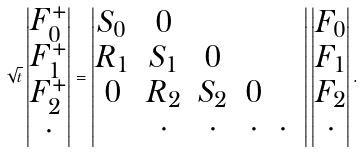Convert formula to latex. <formula><loc_0><loc_0><loc_500><loc_500>\sqrt { t } \begin{vmatrix} F ^ { + } _ { 0 } \\ F ^ { + } _ { 1 } \\ F ^ { + } _ { 2 } \\ \cdot \end{vmatrix} = \begin{vmatrix} S _ { 0 } & 0 & \\ R _ { 1 } & S _ { 1 } & 0 & \\ 0 & R _ { 2 } & S _ { 2 } & 0 & \\ & \cdot & \cdot & \cdot & \cdot & \end{vmatrix} \begin{vmatrix} F _ { 0 } \\ F _ { 1 } \\ F _ { 2 } \\ \cdot \end{vmatrix} .</formula> 